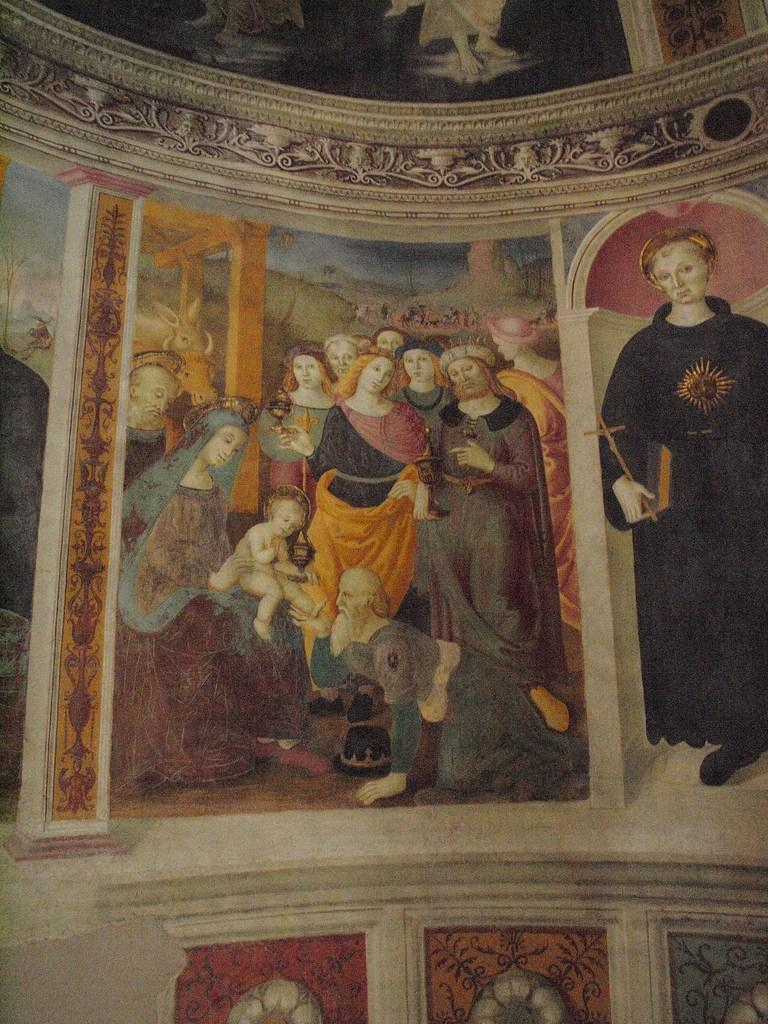What type of artwork is depicted in the image? The image is a painting. What can be seen in the painting? There is a group of people in the painting. What type of sugar is being used by the people in the painting? There is no sugar present in the painting, as it features a group of people but does not mention any specific activities or objects related to sugar. 